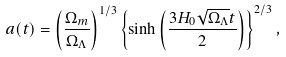Convert formula to latex. <formula><loc_0><loc_0><loc_500><loc_500>a ( t ) = \left ( \frac { \Omega _ { m } } { \Omega _ { \Lambda } } \right ) ^ { 1 / 3 } \left \{ \sinh \left ( \frac { 3 H _ { 0 } \sqrt { \Omega _ { \Lambda } } t } { 2 } \right ) \right \} ^ { 2 / 3 } ,</formula> 